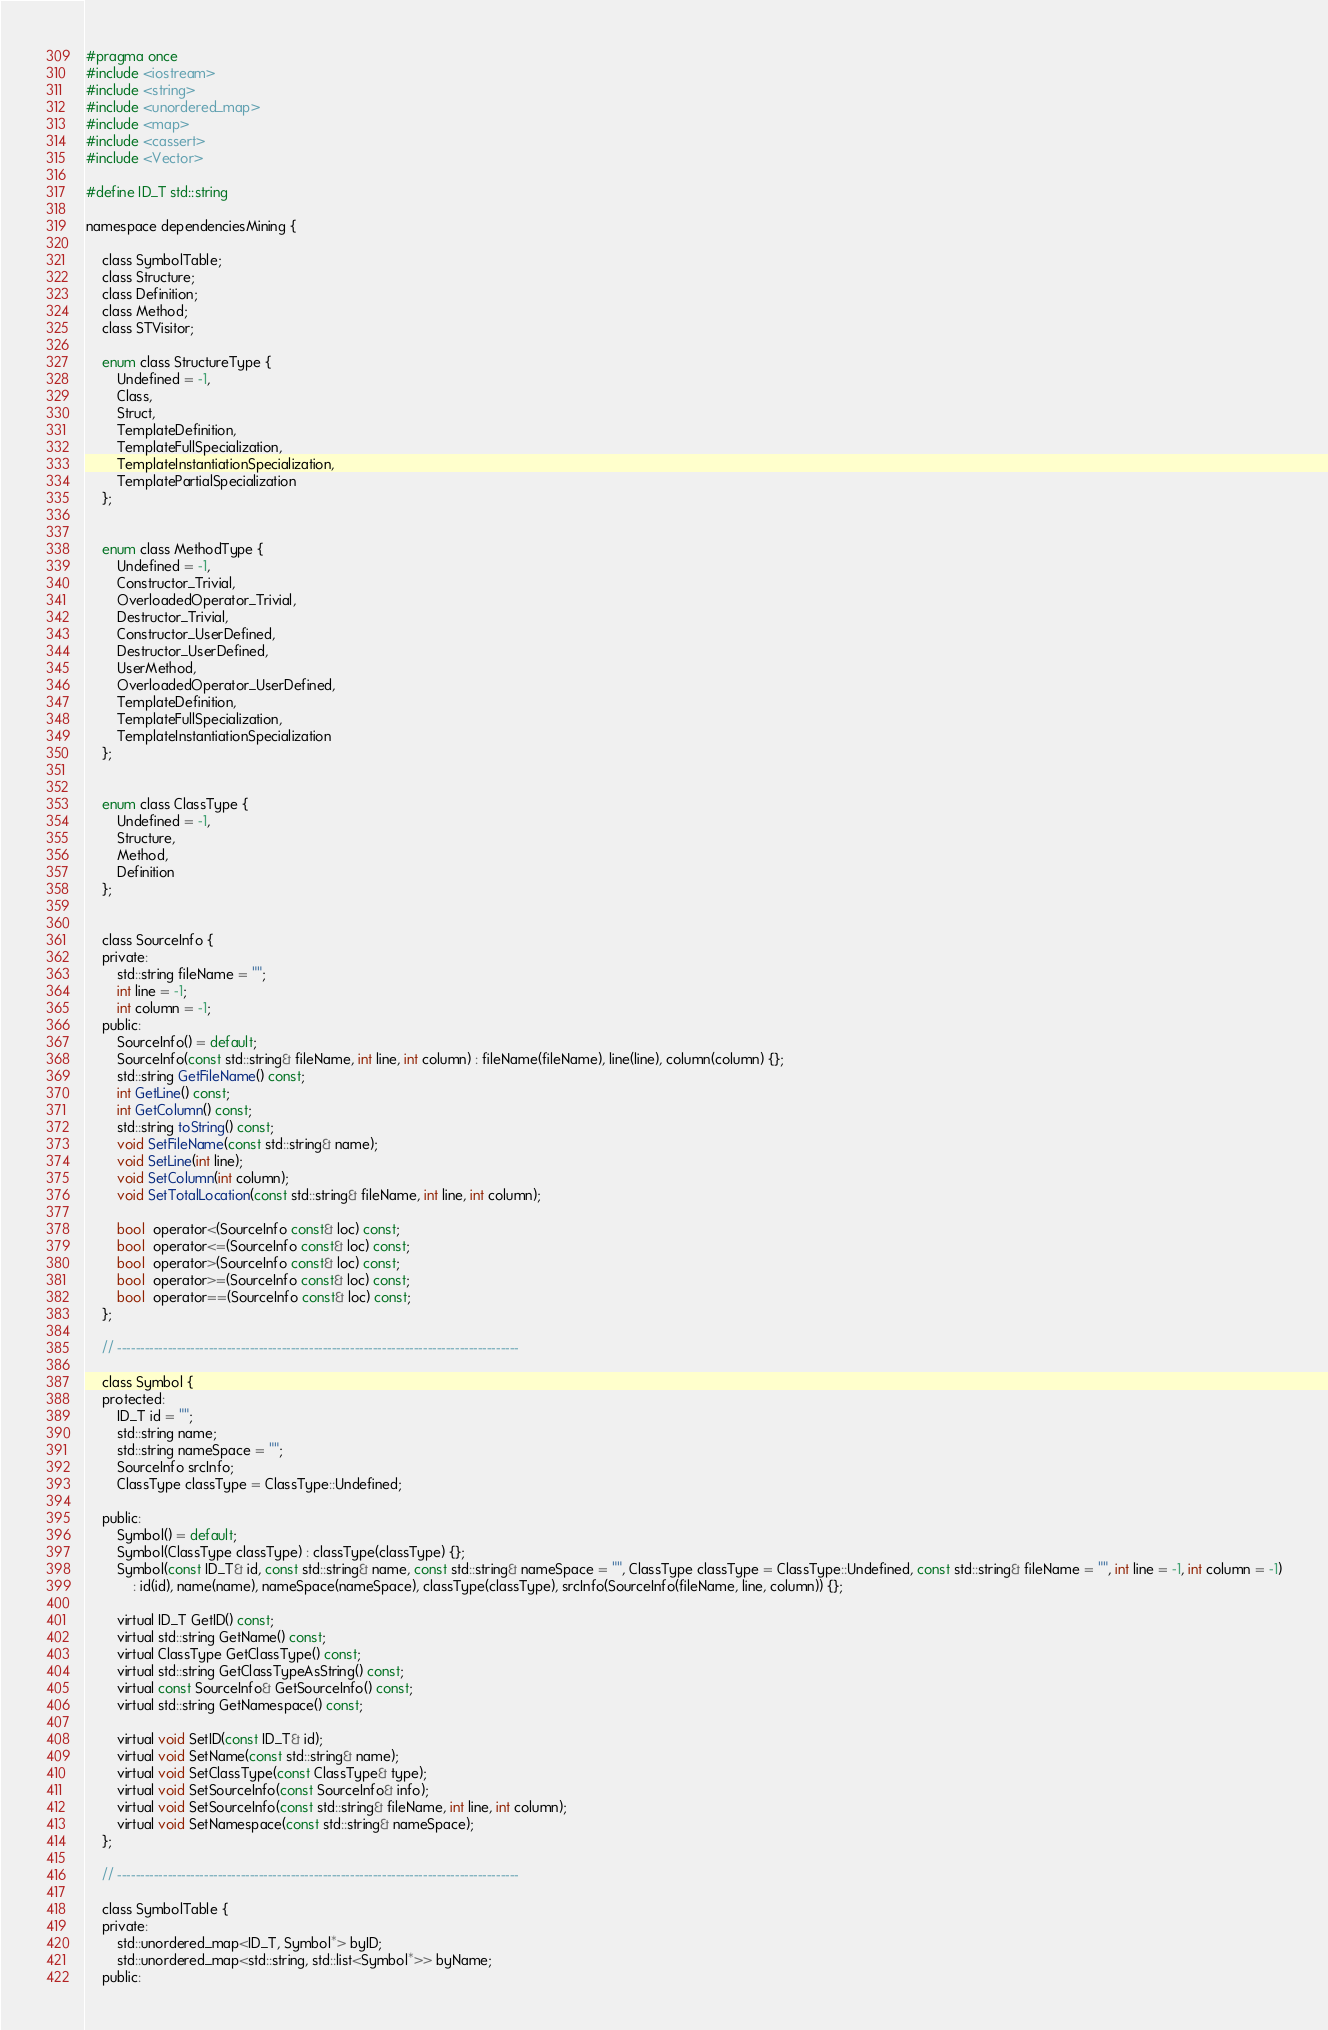<code> <loc_0><loc_0><loc_500><loc_500><_C_>#pragma once
#include <iostream>
#include <string>
#include <unordered_map>
#include <map>
#include <cassert>
#include <Vector>

#define ID_T std::string 

namespace dependenciesMining {

	class SymbolTable;
	class Structure;
	class Definition; 
	class Method;
	class STVisitor;

	enum class StructureType {
		Undefined = -1,
		Class,
		Struct,
		TemplateDefinition,
		TemplateFullSpecialization,
		TemplateInstantiationSpecialization,
		TemplatePartialSpecialization
	};


	enum class MethodType {
		Undefined = -1,
		Constructor_Trivial,
		OverloadedOperator_Trivial,
		Destructor_Trivial,
		Constructor_UserDefined,
		Destructor_UserDefined,
		UserMethod,
		OverloadedOperator_UserDefined,
		TemplateDefinition,
		TemplateFullSpecialization,
		TemplateInstantiationSpecialization
	};


	enum class ClassType {
		Undefined = -1,
		Structure,
		Method, 
		Definition
	};


	class SourceInfo {
	private:
		std::string fileName = "";
		int line = -1;
		int column = -1;
	public:
		SourceInfo() = default;
		SourceInfo(const std::string& fileName, int line, int column) : fileName(fileName), line(line), column(column) {};
		std::string GetFileName() const;
		int GetLine() const;
		int GetColumn() const;
		std::string toString() const;
		void SetFileName(const std::string& name);
		void SetLine(int line);
		void SetColumn(int column);
		void SetTotalLocation(const std::string& fileName, int line, int column);

		bool  operator<(SourceInfo const& loc) const;
		bool  operator<=(SourceInfo const& loc) const;
		bool  operator>(SourceInfo const& loc) const;
		bool  operator>=(SourceInfo const& loc) const;
		bool  operator==(SourceInfo const& loc) const;		
	};

	// ----------------------------------------------------------------------------------------

	class Symbol {
	protected:
		ID_T id = "";
		std::string name;
		std::string nameSpace = "";
		SourceInfo srcInfo;
		ClassType classType = ClassType::Undefined;

	public:
		Symbol() = default; 
		Symbol(ClassType classType) : classType(classType) {};
		Symbol(const ID_T& id, const std::string& name, const std::string& nameSpace = "", ClassType classType = ClassType::Undefined, const std::string& fileName = "", int line = -1, int column = -1)
			: id(id), name(name), nameSpace(nameSpace), classType(classType), srcInfo(SourceInfo(fileName, line, column)) {};

		virtual ID_T GetID() const;
		virtual std::string GetName() const;
		virtual ClassType GetClassType() const;
		virtual std::string GetClassTypeAsString() const;
		virtual const SourceInfo& GetSourceInfo() const;
		virtual std::string GetNamespace() const;

		virtual void SetID(const ID_T& id);
		virtual void SetName(const std::string& name);
		virtual void SetClassType(const ClassType& type);
		virtual void SetSourceInfo(const SourceInfo& info);
		virtual void SetSourceInfo(const std::string& fileName, int line, int column);
		virtual void SetNamespace(const std::string& nameSpace);
	};

	// ----------------------------------------------------------------------------------------

	class SymbolTable {
	private:
		std::unordered_map<ID_T, Symbol*> byID;
		std::unordered_map<std::string, std::list<Symbol*>> byName;
	public:</code> 